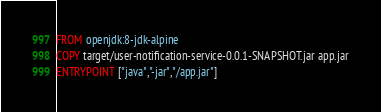Convert code to text. <code><loc_0><loc_0><loc_500><loc_500><_Dockerfile_>FROM openjdk:8-jdk-alpine
COPY target/user-notification-service-0.0.1-SNAPSHOT.jar app.jar
ENTRYPOINT ["java","-jar","/app.jar"]</code> 